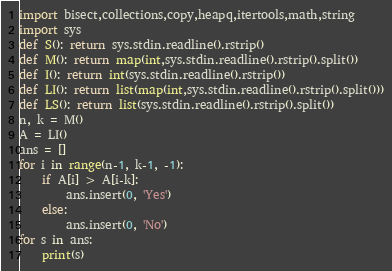Convert code to text. <code><loc_0><loc_0><loc_500><loc_500><_Python_>import bisect,collections,copy,heapq,itertools,math,string
import sys
def S(): return sys.stdin.readline().rstrip()
def M(): return map(int,sys.stdin.readline().rstrip().split())
def I(): return int(sys.stdin.readline().rstrip())
def LI(): return list(map(int,sys.stdin.readline().rstrip().split()))
def LS(): return list(sys.stdin.readline().rstrip().split())
n, k = M()
A = LI()
ans = []
for i in range(n-1, k-1, -1):
    if A[i] > A[i-k]:
        ans.insert(0, 'Yes')
    else:
        ans.insert(0, 'No')
for s in ans:
    print(s)</code> 